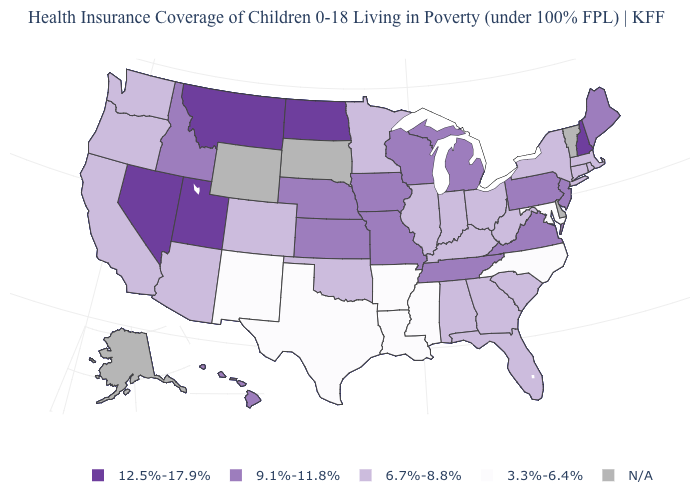What is the value of Washington?
Answer briefly. 6.7%-8.8%. Among the states that border North Carolina , which have the lowest value?
Concise answer only. Georgia, South Carolina. Among the states that border Maine , which have the lowest value?
Keep it brief. New Hampshire. Among the states that border Massachusetts , which have the highest value?
Answer briefly. New Hampshire. What is the lowest value in the MidWest?
Answer briefly. 6.7%-8.8%. Name the states that have a value in the range 9.1%-11.8%?
Be succinct. Hawaii, Idaho, Iowa, Kansas, Maine, Michigan, Missouri, Nebraska, New Jersey, Pennsylvania, Tennessee, Virginia, Wisconsin. Name the states that have a value in the range 12.5%-17.9%?
Write a very short answer. Montana, Nevada, New Hampshire, North Dakota, Utah. What is the value of Michigan?
Short answer required. 9.1%-11.8%. What is the highest value in states that border Delaware?
Concise answer only. 9.1%-11.8%. What is the value of South Dakota?
Answer briefly. N/A. What is the highest value in the West ?
Keep it brief. 12.5%-17.9%. Among the states that border Massachusetts , which have the highest value?
Answer briefly. New Hampshire. Among the states that border Nevada , which have the highest value?
Answer briefly. Utah. 